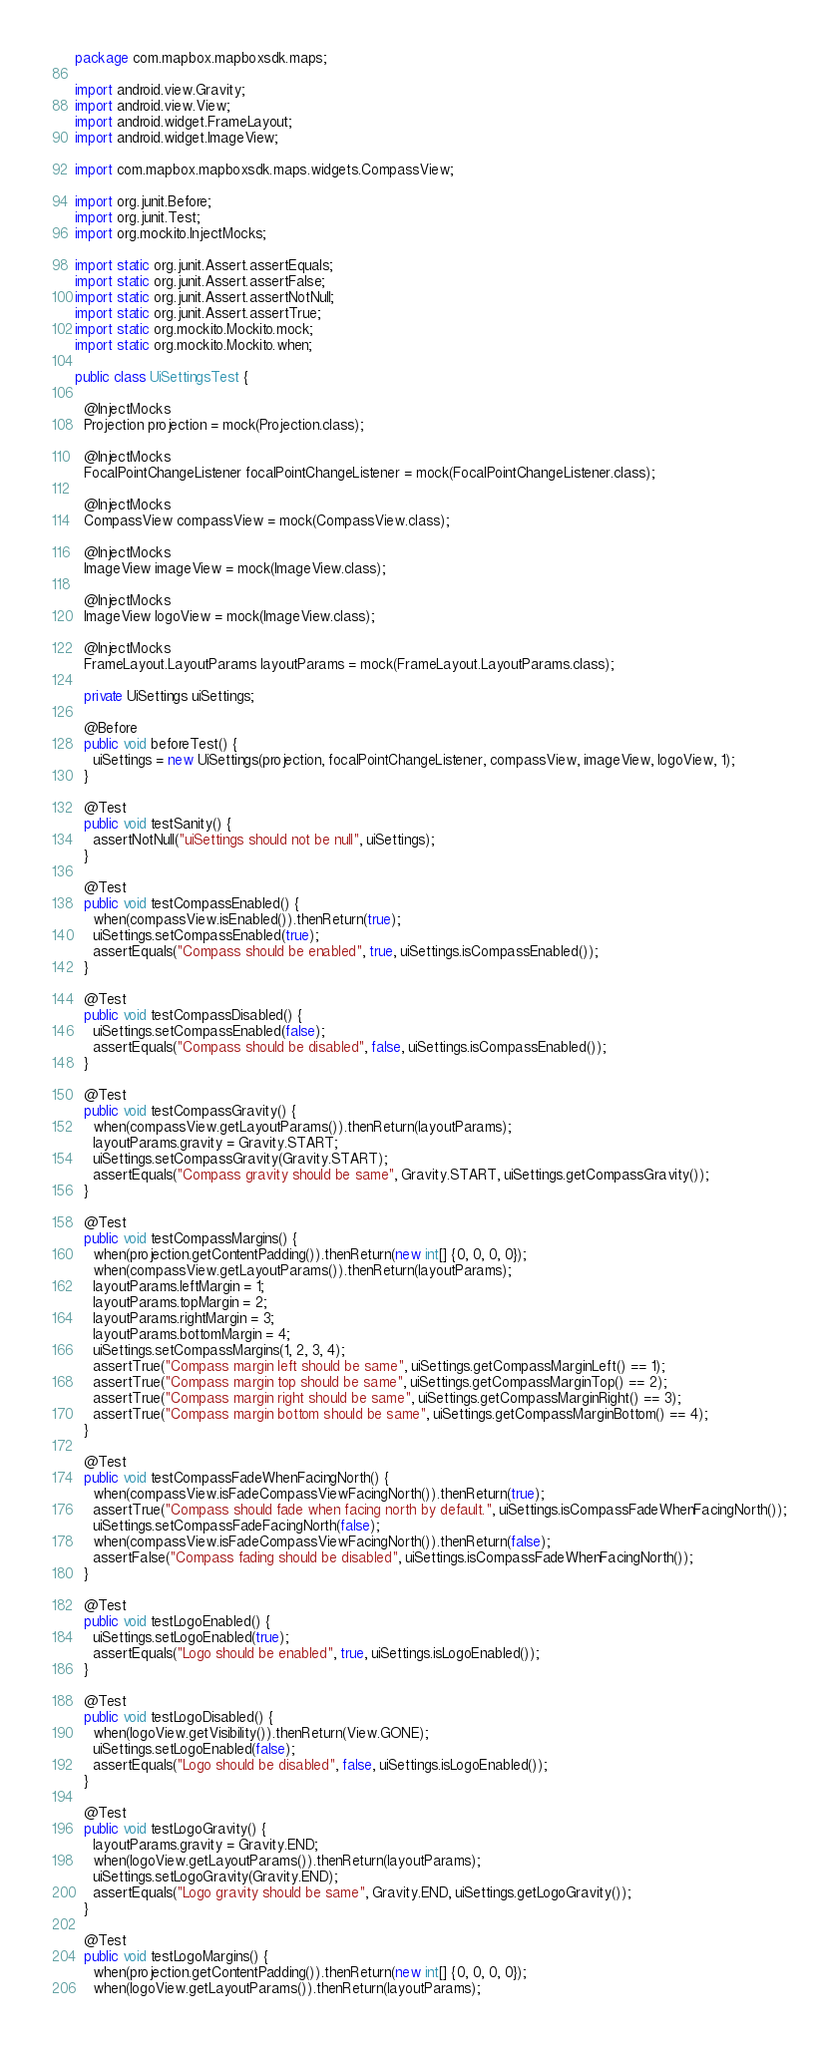<code> <loc_0><loc_0><loc_500><loc_500><_Java_>package com.mapbox.mapboxsdk.maps;

import android.view.Gravity;
import android.view.View;
import android.widget.FrameLayout;
import android.widget.ImageView;

import com.mapbox.mapboxsdk.maps.widgets.CompassView;

import org.junit.Before;
import org.junit.Test;
import org.mockito.InjectMocks;

import static org.junit.Assert.assertEquals;
import static org.junit.Assert.assertFalse;
import static org.junit.Assert.assertNotNull;
import static org.junit.Assert.assertTrue;
import static org.mockito.Mockito.mock;
import static org.mockito.Mockito.when;

public class UiSettingsTest {

  @InjectMocks
  Projection projection = mock(Projection.class);

  @InjectMocks
  FocalPointChangeListener focalPointChangeListener = mock(FocalPointChangeListener.class);

  @InjectMocks
  CompassView compassView = mock(CompassView.class);

  @InjectMocks
  ImageView imageView = mock(ImageView.class);

  @InjectMocks
  ImageView logoView = mock(ImageView.class);

  @InjectMocks
  FrameLayout.LayoutParams layoutParams = mock(FrameLayout.LayoutParams.class);

  private UiSettings uiSettings;

  @Before
  public void beforeTest() {
    uiSettings = new UiSettings(projection, focalPointChangeListener, compassView, imageView, logoView, 1);
  }

  @Test
  public void testSanity() {
    assertNotNull("uiSettings should not be null", uiSettings);
  }

  @Test
  public void testCompassEnabled() {
    when(compassView.isEnabled()).thenReturn(true);
    uiSettings.setCompassEnabled(true);
    assertEquals("Compass should be enabled", true, uiSettings.isCompassEnabled());
  }

  @Test
  public void testCompassDisabled() {
    uiSettings.setCompassEnabled(false);
    assertEquals("Compass should be disabled", false, uiSettings.isCompassEnabled());
  }

  @Test
  public void testCompassGravity() {
    when(compassView.getLayoutParams()).thenReturn(layoutParams);
    layoutParams.gravity = Gravity.START;
    uiSettings.setCompassGravity(Gravity.START);
    assertEquals("Compass gravity should be same", Gravity.START, uiSettings.getCompassGravity());
  }

  @Test
  public void testCompassMargins() {
    when(projection.getContentPadding()).thenReturn(new int[] {0, 0, 0, 0});
    when(compassView.getLayoutParams()).thenReturn(layoutParams);
    layoutParams.leftMargin = 1;
    layoutParams.topMargin = 2;
    layoutParams.rightMargin = 3;
    layoutParams.bottomMargin = 4;
    uiSettings.setCompassMargins(1, 2, 3, 4);
    assertTrue("Compass margin left should be same", uiSettings.getCompassMarginLeft() == 1);
    assertTrue("Compass margin top should be same", uiSettings.getCompassMarginTop() == 2);
    assertTrue("Compass margin right should be same", uiSettings.getCompassMarginRight() == 3);
    assertTrue("Compass margin bottom should be same", uiSettings.getCompassMarginBottom() == 4);
  }

  @Test
  public void testCompassFadeWhenFacingNorth() {
    when(compassView.isFadeCompassViewFacingNorth()).thenReturn(true);
    assertTrue("Compass should fade when facing north by default.", uiSettings.isCompassFadeWhenFacingNorth());
    uiSettings.setCompassFadeFacingNorth(false);
    when(compassView.isFadeCompassViewFacingNorth()).thenReturn(false);
    assertFalse("Compass fading should be disabled", uiSettings.isCompassFadeWhenFacingNorth());
  }

  @Test
  public void testLogoEnabled() {
    uiSettings.setLogoEnabled(true);
    assertEquals("Logo should be enabled", true, uiSettings.isLogoEnabled());
  }

  @Test
  public void testLogoDisabled() {
    when(logoView.getVisibility()).thenReturn(View.GONE);
    uiSettings.setLogoEnabled(false);
    assertEquals("Logo should be disabled", false, uiSettings.isLogoEnabled());
  }

  @Test
  public void testLogoGravity() {
    layoutParams.gravity = Gravity.END;
    when(logoView.getLayoutParams()).thenReturn(layoutParams);
    uiSettings.setLogoGravity(Gravity.END);
    assertEquals("Logo gravity should be same", Gravity.END, uiSettings.getLogoGravity());
  }

  @Test
  public void testLogoMargins() {
    when(projection.getContentPadding()).thenReturn(new int[] {0, 0, 0, 0});
    when(logoView.getLayoutParams()).thenReturn(layoutParams);</code> 